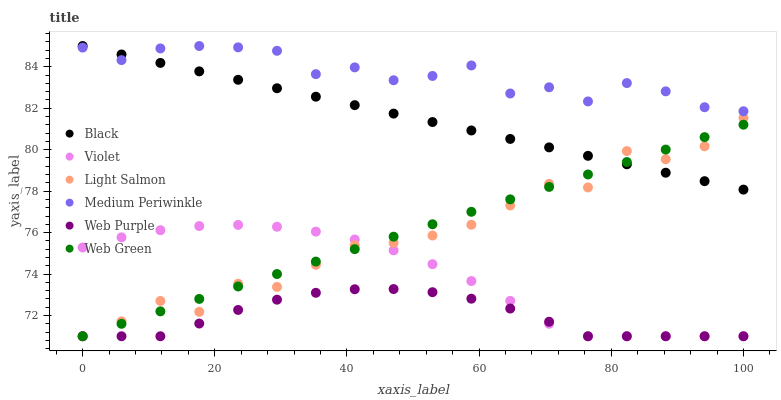Does Web Purple have the minimum area under the curve?
Answer yes or no. Yes. Does Medium Periwinkle have the maximum area under the curve?
Answer yes or no. Yes. Does Web Green have the minimum area under the curve?
Answer yes or no. No. Does Web Green have the maximum area under the curve?
Answer yes or no. No. Is Web Green the smoothest?
Answer yes or no. Yes. Is Light Salmon the roughest?
Answer yes or no. Yes. Is Medium Periwinkle the smoothest?
Answer yes or no. No. Is Medium Periwinkle the roughest?
Answer yes or no. No. Does Light Salmon have the lowest value?
Answer yes or no. Yes. Does Medium Periwinkle have the lowest value?
Answer yes or no. No. Does Black have the highest value?
Answer yes or no. Yes. Does Web Green have the highest value?
Answer yes or no. No. Is Violet less than Black?
Answer yes or no. Yes. Is Medium Periwinkle greater than Web Green?
Answer yes or no. Yes. Does Web Purple intersect Violet?
Answer yes or no. Yes. Is Web Purple less than Violet?
Answer yes or no. No. Is Web Purple greater than Violet?
Answer yes or no. No. Does Violet intersect Black?
Answer yes or no. No. 